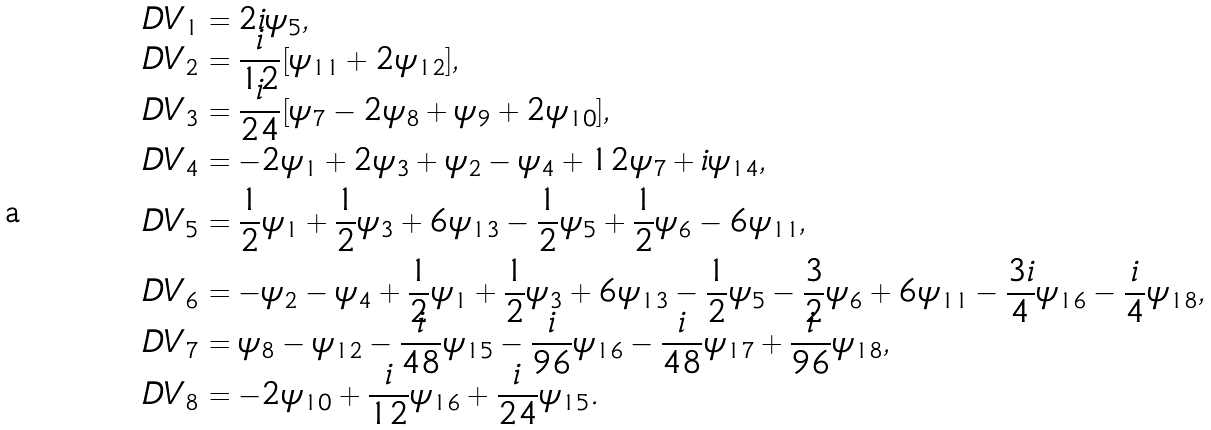Convert formula to latex. <formula><loc_0><loc_0><loc_500><loc_500>\ D V _ { 1 } & = 2 i \psi _ { 5 } , \\ \ D V _ { 2 } & = \frac { i } { 1 2 } [ \psi _ { 1 1 } + 2 \psi _ { 1 2 } ] , \\ \ D V _ { 3 } & = \frac { i } { 2 4 } [ \psi _ { 7 } - 2 \psi _ { 8 } + \psi _ { 9 } + 2 \psi _ { 1 0 } ] , \\ \ D V _ { 4 } & = - 2 \psi _ { 1 } + 2 \psi _ { 3 } + \psi _ { 2 } - \psi _ { 4 } + 1 2 \psi _ { 7 } + i \psi _ { 1 4 } , \\ \ D V _ { 5 } & = \frac { 1 } { 2 } \psi _ { 1 } + \frac { 1 } { 2 } \psi _ { 3 } + 6 \psi _ { 1 3 } - \frac { 1 } { 2 } \psi _ { 5 } + \frac { 1 } { 2 } \psi _ { 6 } - 6 \psi _ { 1 1 } , \\ \ D V _ { 6 } & = - \psi _ { 2 } - \psi _ { 4 } + \frac { 1 } { 2 } \psi _ { 1 } + \frac { 1 } { 2 } \psi _ { 3 } + 6 \psi _ { 1 3 } - \frac { 1 } { 2 } \psi _ { 5 } - \frac { 3 } { 2 } \psi _ { 6 } + 6 \psi _ { 1 1 } - \frac { 3 i } { 4 } \psi _ { 1 6 } - \frac { i } { 4 } \psi _ { 1 8 } , \\ \ D V _ { 7 } & = \psi _ { 8 } - \psi _ { 1 2 } - \frac { i } { 4 8 } \psi _ { 1 5 } - \frac { i } { 9 6 } \psi _ { 1 6 } - \frac { i } { 4 8 } \psi _ { 1 7 } + \frac { i } { 9 6 } \psi _ { 1 8 } , \\ \ D V _ { 8 } & = - 2 \psi _ { 1 0 } + \frac { i } { 1 2 } \psi _ { 1 6 } + \frac { i } { 2 4 } \psi _ { 1 5 } .</formula> 